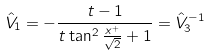<formula> <loc_0><loc_0><loc_500><loc_500>\hat { V } _ { 1 } = - \frac { t - 1 } { t \tan ^ { 2 } \frac { x ^ { + } } { \sqrt { 2 } } + 1 } = \hat { V } _ { 3 } ^ { - 1 }</formula> 